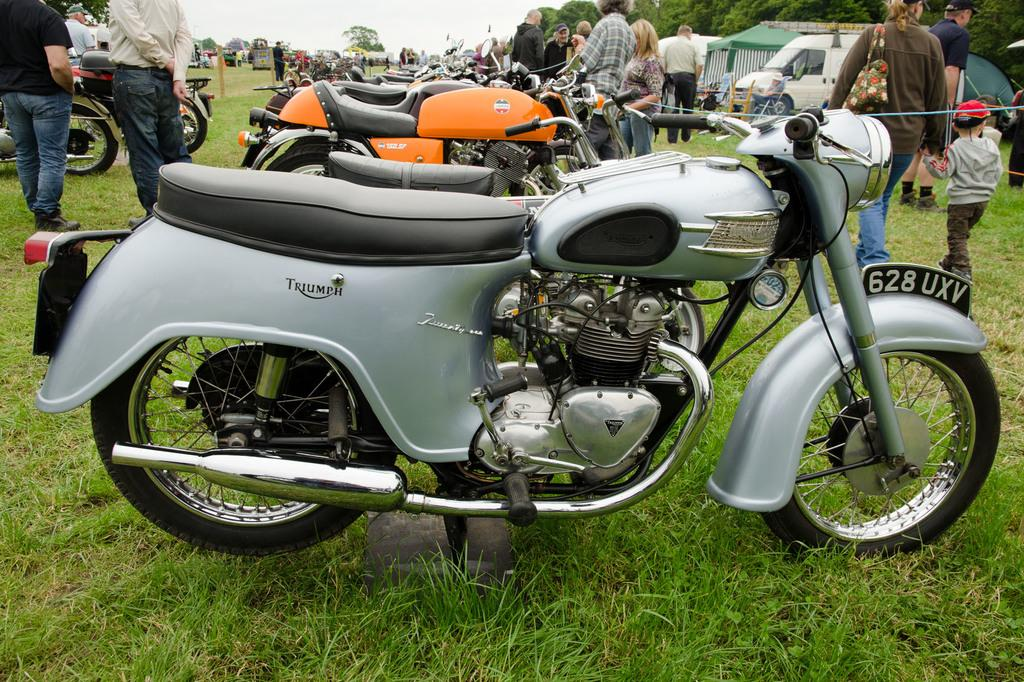What are the bikes doing in the image? The bikes are parked on the grass in the image. Where are the bikes located in relation to the ground? The bikes are on the ground in the image. What are the people near the bikes doing? People are standing and walking near the bikes in the image. What can be seen in the background of the image? There are vehicles, trees, and the sky visible in the background of the image. What type of art can be seen on the turkey in the image? There is no turkey present in the image, and therefore no art can be observed on it. 